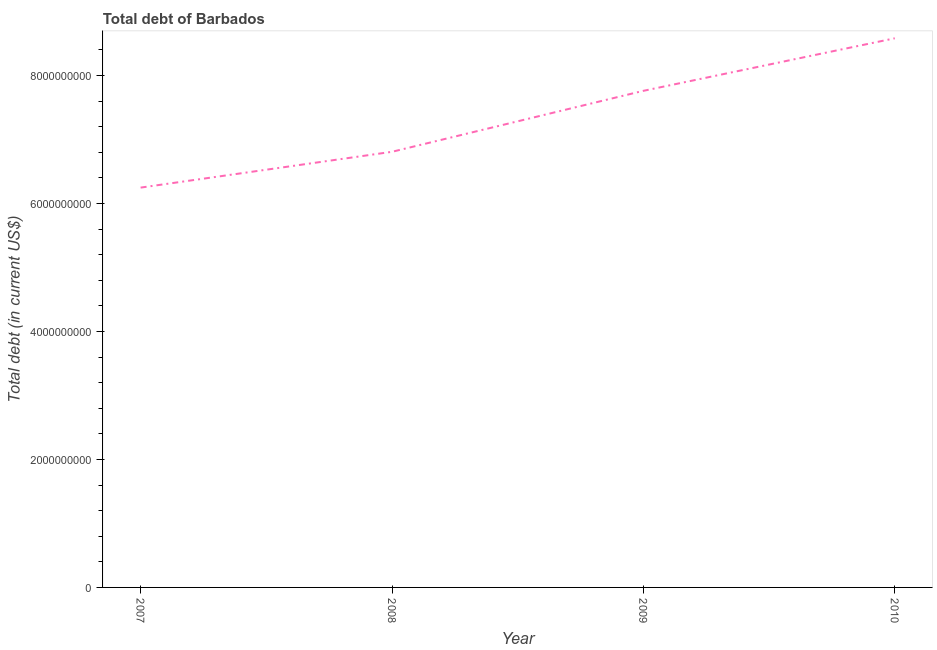What is the total debt in 2007?
Provide a short and direct response. 6.25e+09. Across all years, what is the maximum total debt?
Your answer should be very brief. 8.58e+09. Across all years, what is the minimum total debt?
Give a very brief answer. 6.25e+09. In which year was the total debt maximum?
Your answer should be compact. 2010. What is the sum of the total debt?
Your answer should be very brief. 2.94e+1. What is the difference between the total debt in 2007 and 2009?
Provide a succinct answer. -1.51e+09. What is the average total debt per year?
Provide a succinct answer. 7.35e+09. What is the median total debt?
Provide a succinct answer. 7.28e+09. In how many years, is the total debt greater than 3600000000 US$?
Provide a short and direct response. 4. Do a majority of the years between 2010 and 2008 (inclusive) have total debt greater than 5200000000 US$?
Your answer should be very brief. No. What is the ratio of the total debt in 2007 to that in 2008?
Ensure brevity in your answer.  0.92. What is the difference between the highest and the second highest total debt?
Ensure brevity in your answer.  8.21e+08. Is the sum of the total debt in 2007 and 2010 greater than the maximum total debt across all years?
Provide a short and direct response. Yes. What is the difference between the highest and the lowest total debt?
Offer a terse response. 2.33e+09. Are the values on the major ticks of Y-axis written in scientific E-notation?
Your answer should be compact. No. What is the title of the graph?
Keep it short and to the point. Total debt of Barbados. What is the label or title of the X-axis?
Your response must be concise. Year. What is the label or title of the Y-axis?
Ensure brevity in your answer.  Total debt (in current US$). What is the Total debt (in current US$) of 2007?
Offer a terse response. 6.25e+09. What is the Total debt (in current US$) of 2008?
Keep it short and to the point. 6.81e+09. What is the Total debt (in current US$) in 2009?
Offer a very short reply. 7.76e+09. What is the Total debt (in current US$) in 2010?
Make the answer very short. 8.58e+09. What is the difference between the Total debt (in current US$) in 2007 and 2008?
Provide a succinct answer. -5.60e+08. What is the difference between the Total debt (in current US$) in 2007 and 2009?
Offer a very short reply. -1.51e+09. What is the difference between the Total debt (in current US$) in 2007 and 2010?
Your answer should be compact. -2.33e+09. What is the difference between the Total debt (in current US$) in 2008 and 2009?
Offer a very short reply. -9.53e+08. What is the difference between the Total debt (in current US$) in 2008 and 2010?
Your response must be concise. -1.77e+09. What is the difference between the Total debt (in current US$) in 2009 and 2010?
Offer a very short reply. -8.21e+08. What is the ratio of the Total debt (in current US$) in 2007 to that in 2008?
Your answer should be compact. 0.92. What is the ratio of the Total debt (in current US$) in 2007 to that in 2009?
Offer a terse response. 0.81. What is the ratio of the Total debt (in current US$) in 2007 to that in 2010?
Your answer should be very brief. 0.73. What is the ratio of the Total debt (in current US$) in 2008 to that in 2009?
Ensure brevity in your answer.  0.88. What is the ratio of the Total debt (in current US$) in 2008 to that in 2010?
Offer a very short reply. 0.79. What is the ratio of the Total debt (in current US$) in 2009 to that in 2010?
Provide a succinct answer. 0.9. 